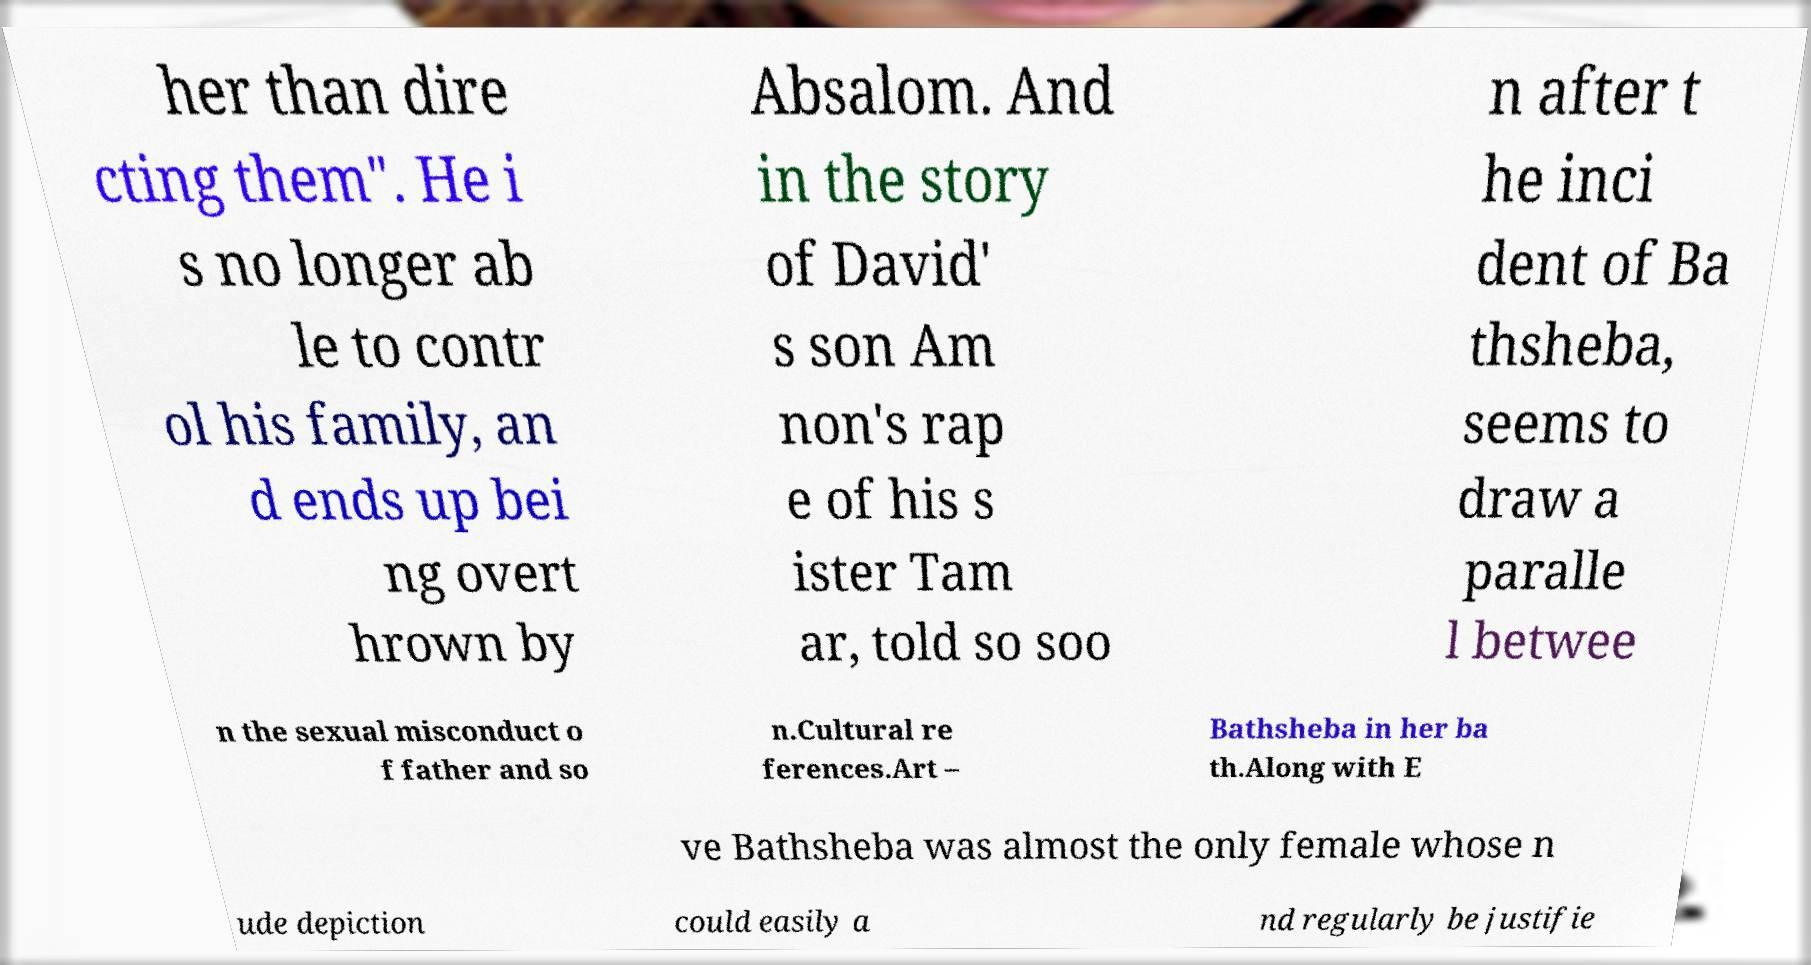What messages or text are displayed in this image? I need them in a readable, typed format. her than dire cting them". He i s no longer ab le to contr ol his family, an d ends up bei ng overt hrown by Absalom. And in the story of David' s son Am non's rap e of his s ister Tam ar, told so soo n after t he inci dent of Ba thsheba, seems to draw a paralle l betwee n the sexual misconduct o f father and so n.Cultural re ferences.Art – Bathsheba in her ba th.Along with E ve Bathsheba was almost the only female whose n ude depiction could easily a nd regularly be justifie 